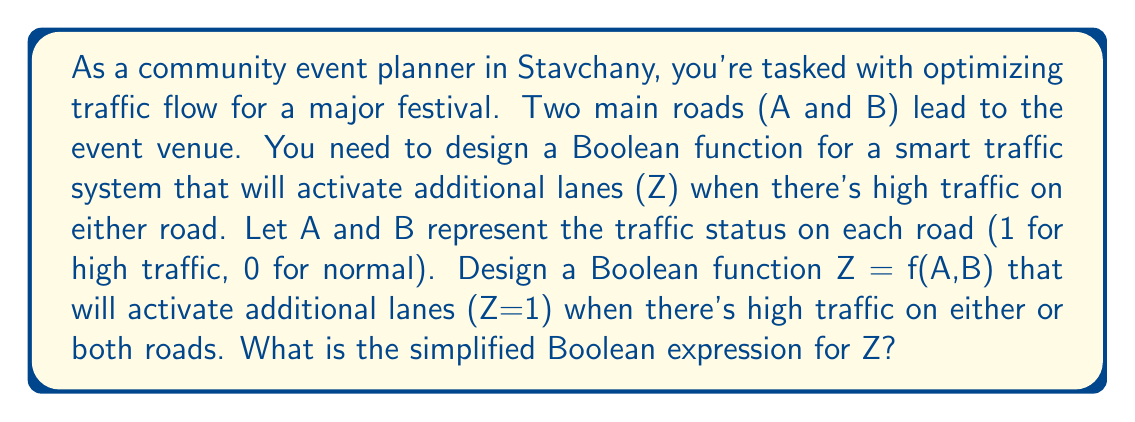What is the answer to this math problem? Let's approach this step-by-step:

1) We need Z to be 1 (activate additional lanes) when either A or B or both are 1 (high traffic).

2) This scenario can be represented by the following truth table:

   A | B | Z
   0 | 0 | 0
   0 | 1 | 1
   1 | 0 | 1
   1 | 1 | 1

3) From this truth table, we can write the Boolean function as:

   $$Z = \overline{A}B + A\overline{B} + AB$$

4) This expression can be simplified using Boolean algebra laws:

   $$Z = \overline{A}B + A\overline{B} + AB$$
   $$= \overline{A}B + A(\overline{B} + B)$$ (Distributive law)
   $$= \overline{A}B + A$$ (Complement law: $\overline{B} + B = 1$)
   $$= \overline{A}B + A(\overline{B} + B)$$ (Identity law: $A = A(1) = A(\overline{B} + B)$)
   $$= \overline{A}B + A\overline{B} + AB$$ (Distributive law)
   $$= A + B$$ (OR law: $X + \overline{X}Y = X + Y$)

5) Therefore, the simplified Boolean expression for Z is $A + B$.
Answer: $Z = A + B$ 